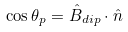<formula> <loc_0><loc_0><loc_500><loc_500>\cos { \theta _ { p } } = \hat { B } _ { d i p } \cdot \hat { n }</formula> 